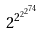<formula> <loc_0><loc_0><loc_500><loc_500>2 ^ { 2 ^ { 2 ^ { 2 ^ { 7 4 } } } }</formula> 